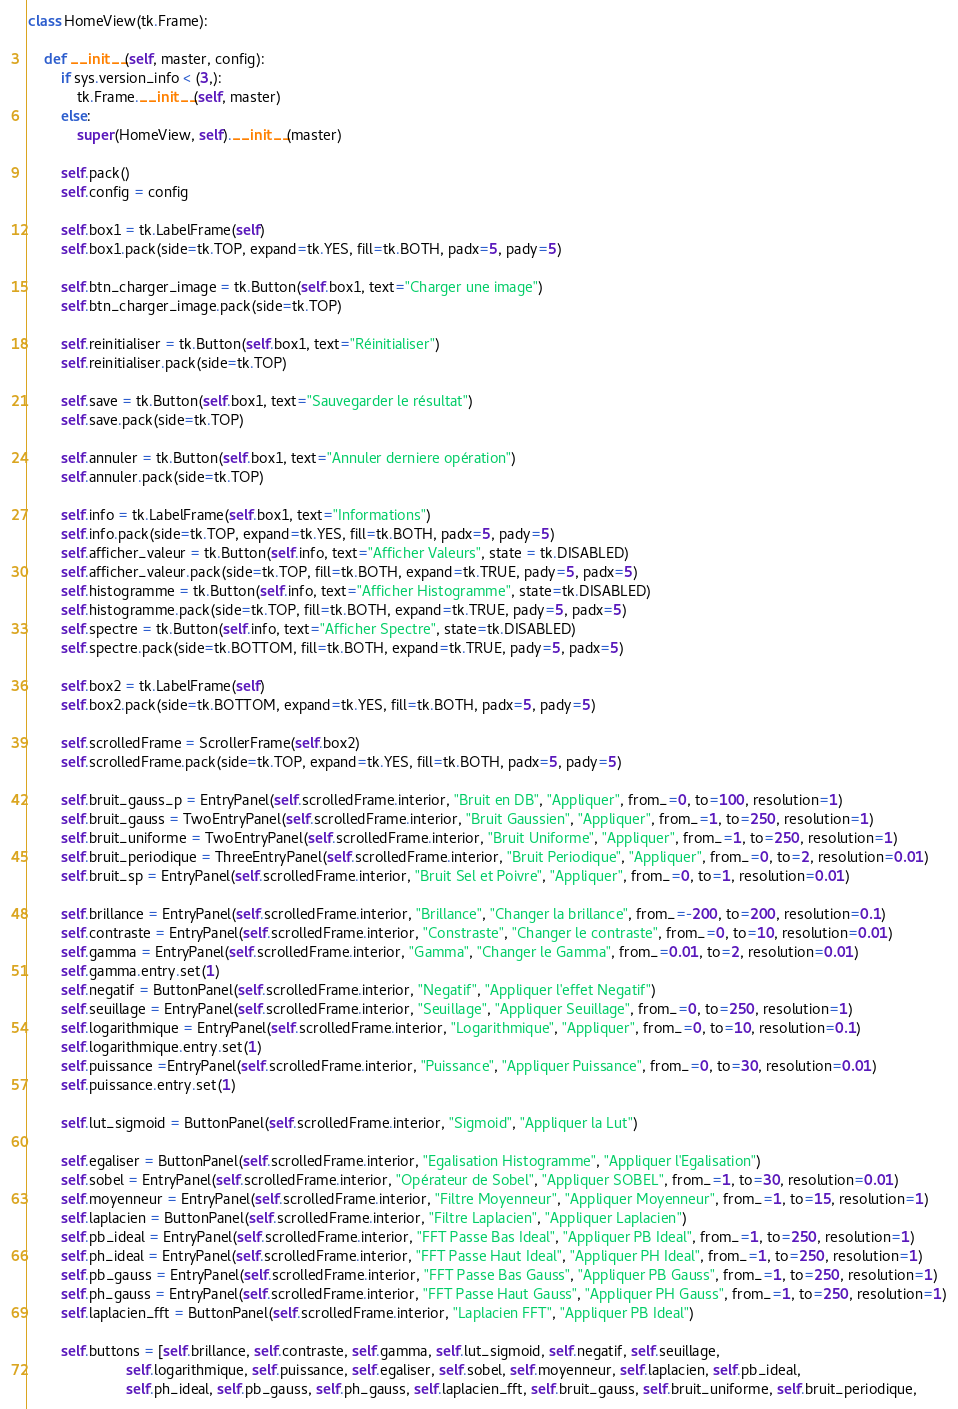<code> <loc_0><loc_0><loc_500><loc_500><_Python_>class HomeView(tk.Frame):

    def __init__(self, master, config):
        if sys.version_info < (3,):
            tk.Frame.__init__(self, master)
        else:
            super(HomeView, self).__init__(master)

        self.pack()
        self.config = config

        self.box1 = tk.LabelFrame(self)
        self.box1.pack(side=tk.TOP, expand=tk.YES, fill=tk.BOTH, padx=5, pady=5)
        
        self.btn_charger_image = tk.Button(self.box1, text="Charger une image")
        self.btn_charger_image.pack(side=tk.TOP)

        self.reinitialiser = tk.Button(self.box1, text="Réinitialiser")
        self.reinitialiser.pack(side=tk.TOP)
        
        self.save = tk.Button(self.box1, text="Sauvegarder le résultat")
        self.save.pack(side=tk.TOP)

        self.annuler = tk.Button(self.box1, text="Annuler derniere opération")
        self.annuler.pack(side=tk.TOP)

        self.info = tk.LabelFrame(self.box1, text="Informations")
        self.info.pack(side=tk.TOP, expand=tk.YES, fill=tk.BOTH, padx=5, pady=5)
        self.afficher_valeur = tk.Button(self.info, text="Afficher Valeurs", state = tk.DISABLED)
        self.afficher_valeur.pack(side=tk.TOP, fill=tk.BOTH, expand=tk.TRUE, pady=5, padx=5)
        self.histogramme = tk.Button(self.info, text="Afficher Histogramme", state=tk.DISABLED)
        self.histogramme.pack(side=tk.TOP, fill=tk.BOTH, expand=tk.TRUE, pady=5, padx=5)
        self.spectre = tk.Button(self.info, text="Afficher Spectre", state=tk.DISABLED)
        self.spectre.pack(side=tk.BOTTOM, fill=tk.BOTH, expand=tk.TRUE, pady=5, padx=5)

        self.box2 = tk.LabelFrame(self)
        self.box2.pack(side=tk.BOTTOM, expand=tk.YES, fill=tk.BOTH, padx=5, pady=5)  

        self.scrolledFrame = ScrollerFrame(self.box2)
        self.scrolledFrame.pack(side=tk.TOP, expand=tk.YES, fill=tk.BOTH, padx=5, pady=5)

        self.bruit_gauss_p = EntryPanel(self.scrolledFrame.interior, "Bruit en DB", "Appliquer", from_=0, to=100, resolution=1)
        self.bruit_gauss = TwoEntryPanel(self.scrolledFrame.interior, "Bruit Gaussien", "Appliquer", from_=1, to=250, resolution=1)
        self.bruit_uniforme = TwoEntryPanel(self.scrolledFrame.interior, "Bruit Uniforme", "Appliquer", from_=1, to=250, resolution=1)
        self.bruit_periodique = ThreeEntryPanel(self.scrolledFrame.interior, "Bruit Periodique", "Appliquer", from_=0, to=2, resolution=0.01)
        self.bruit_sp = EntryPanel(self.scrolledFrame.interior, "Bruit Sel et Poivre", "Appliquer", from_=0, to=1, resolution=0.01)

        self.brillance = EntryPanel(self.scrolledFrame.interior, "Brillance", "Changer la brillance", from_=-200, to=200, resolution=0.1)
        self.contraste = EntryPanel(self.scrolledFrame.interior, "Constraste", "Changer le contraste", from_=0, to=10, resolution=0.01)
        self.gamma = EntryPanel(self.scrolledFrame.interior, "Gamma", "Changer le Gamma", from_=0.01, to=2, resolution=0.01)
        self.gamma.entry.set(1)
        self.negatif = ButtonPanel(self.scrolledFrame.interior, "Negatif", "Appliquer l'effet Negatif")
        self.seuillage = EntryPanel(self.scrolledFrame.interior, "Seuillage", "Appliquer Seuillage", from_=0, to=250, resolution=1)
        self.logarithmique = EntryPanel(self.scrolledFrame.interior, "Logarithmique", "Appliquer", from_=0, to=10, resolution=0.1)
        self.logarithmique.entry.set(1)
        self.puissance =EntryPanel(self.scrolledFrame.interior, "Puissance", "Appliquer Puissance", from_=0, to=30, resolution=0.01)
        self.puissance.entry.set(1)

        self.lut_sigmoid = ButtonPanel(self.scrolledFrame.interior, "Sigmoid", "Appliquer la Lut")
        
        self.egaliser = ButtonPanel(self.scrolledFrame.interior, "Egalisation Histogramme", "Appliquer l'Egalisation")
        self.sobel = EntryPanel(self.scrolledFrame.interior, "Opérateur de Sobel", "Appliquer SOBEL", from_=1, to=30, resolution=0.01)
        self.moyenneur = EntryPanel(self.scrolledFrame.interior, "Filtre Moyenneur", "Appliquer Moyenneur", from_=1, to=15, resolution=1)
        self.laplacien = ButtonPanel(self.scrolledFrame.interior, "Filtre Laplacien", "Appliquer Laplacien")
        self.pb_ideal = EntryPanel(self.scrolledFrame.interior, "FFT Passe Bas Ideal", "Appliquer PB Ideal", from_=1, to=250, resolution=1)
        self.ph_ideal = EntryPanel(self.scrolledFrame.interior, "FFT Passe Haut Ideal", "Appliquer PH Ideal", from_=1, to=250, resolution=1)
        self.pb_gauss = EntryPanel(self.scrolledFrame.interior, "FFT Passe Bas Gauss", "Appliquer PB Gauss", from_=1, to=250, resolution=1)
        self.ph_gauss = EntryPanel(self.scrolledFrame.interior, "FFT Passe Haut Gauss", "Appliquer PH Gauss", from_=1, to=250, resolution=1)
        self.laplacien_fft = ButtonPanel(self.scrolledFrame.interior, "Laplacien FFT", "Appliquer PB Ideal")

        self.buttons = [self.brillance, self.contraste, self.gamma, self.lut_sigmoid, self.negatif, self.seuillage,
                        self.logarithmique, self.puissance, self.egaliser, self.sobel, self.moyenneur, self.laplacien, self.pb_ideal,
                        self.ph_ideal, self.pb_gauss, self.ph_gauss, self.laplacien_fft, self.bruit_gauss, self.bruit_uniforme, self.bruit_periodique,</code> 